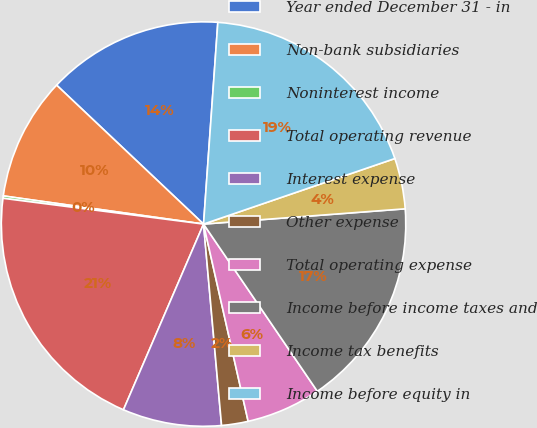Convert chart to OTSL. <chart><loc_0><loc_0><loc_500><loc_500><pie_chart><fcel>Year ended December 31 - in<fcel>Non-bank subsidiaries<fcel>Noninterest income<fcel>Total operating revenue<fcel>Interest expense<fcel>Other expense<fcel>Total operating expense<fcel>Income before income taxes and<fcel>Income tax benefits<fcel>Income before equity in<nl><fcel>14.07%<fcel>9.83%<fcel>0.19%<fcel>20.55%<fcel>7.9%<fcel>2.12%<fcel>5.97%<fcel>16.69%<fcel>4.05%<fcel>18.62%<nl></chart> 